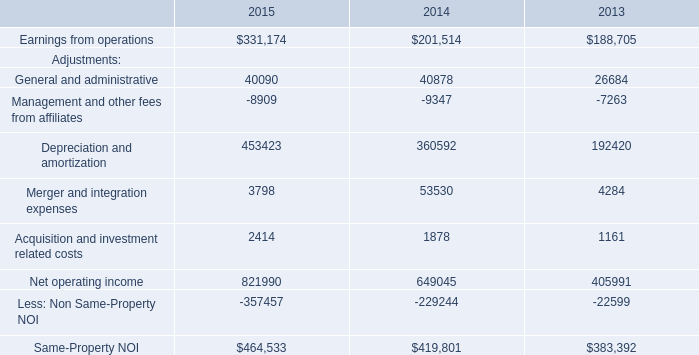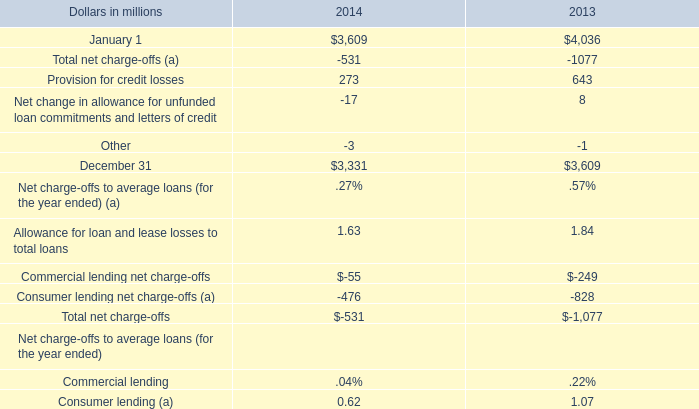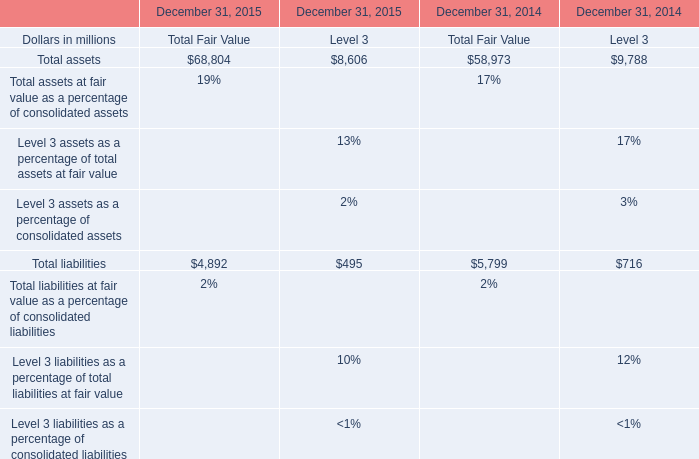What was the total amount of the Total liabilities in the years where Total assets greater than 0? (in million) 
Computations: (((4892 + 495) + 5799) + 716)
Answer: 11902.0. 